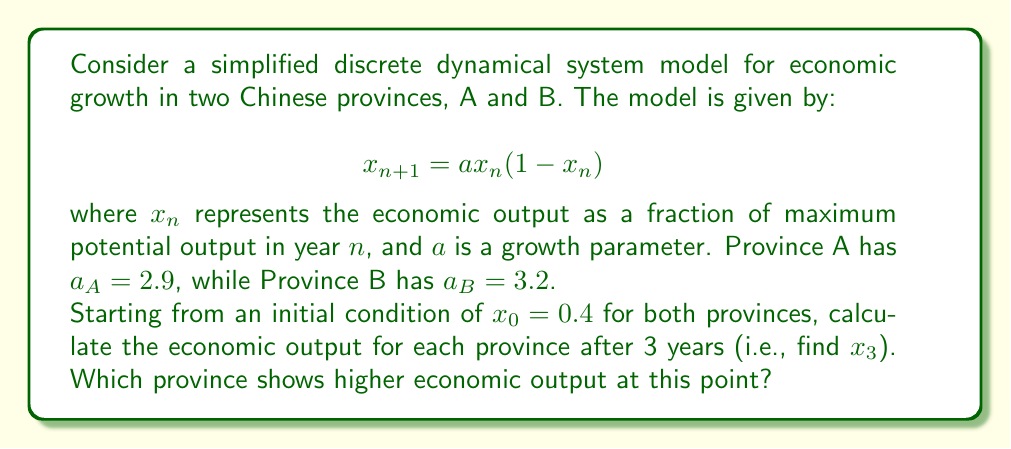Could you help me with this problem? Let's solve this step-by-step for each province:

Province A ($a_A = 2.9$):

1) For $n = 0$:
   $x_1 = 2.9 \cdot 0.4 \cdot (1-0.4) = 2.9 \cdot 0.4 \cdot 0.6 = 0.696$

2) For $n = 1$:
   $x_2 = 2.9 \cdot 0.696 \cdot (1-0.696) = 2.9 \cdot 0.696 \cdot 0.304 = 0.613824$

3) For $n = 2$:
   $x_3 = 2.9 \cdot 0.613824 \cdot (1-0.613824) = 2.9 \cdot 0.613824 \cdot 0.386176 \approx 0.6871$

Province B ($a_B = 3.2$):

1) For $n = 0$:
   $x_1 = 3.2 \cdot 0.4 \cdot (1-0.4) = 3.2 \cdot 0.4 \cdot 0.6 = 0.768$

2) For $n = 1$:
   $x_2 = 3.2 \cdot 0.768 \cdot (1-0.768) = 3.2 \cdot 0.768 \cdot 0.232 = 0.570982$

3) For $n = 2$:
   $x_3 = 3.2 \cdot 0.570982 \cdot (1-0.570982) = 3.2 \cdot 0.570982 \cdot 0.429018 \approx 0.7844$

Comparing the results, we see that Province B has a higher economic output after 3 years.
Answer: Province B, with $x_3 \approx 0.7844$ 